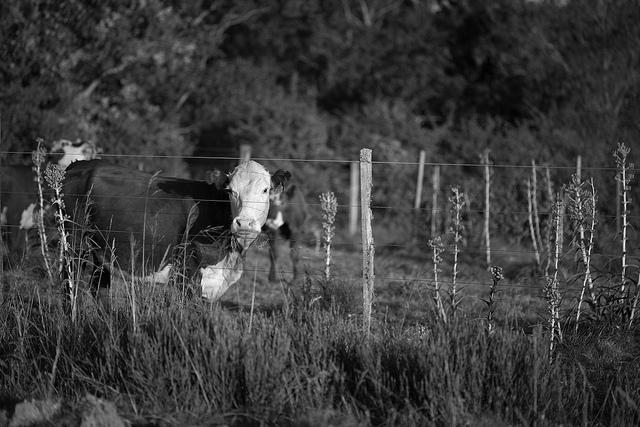Where is the animal looking?
Quick response, please. At camera. Is there something flying in the sky?
Answer briefly. No. Is this a wire fence?
Answer briefly. Yes. What kind of animal is in this photo?
Short answer required. Cow. 